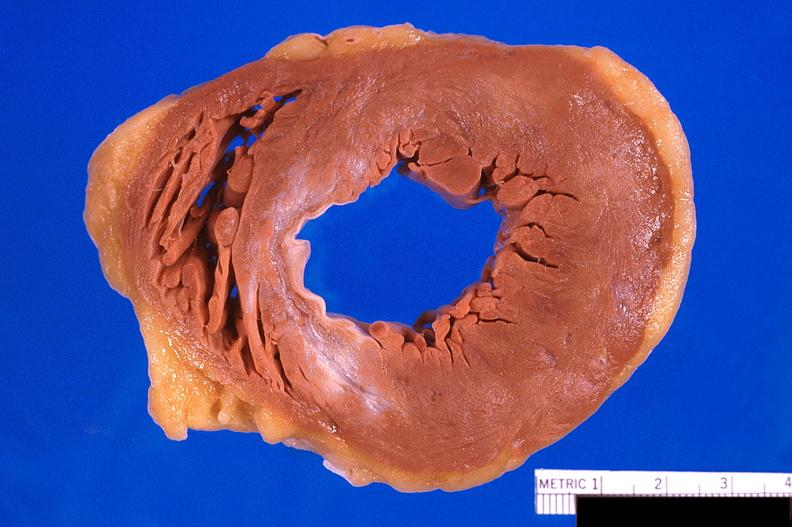how does this image show heart, old myocardial infarction?
Answer the question using a single word or phrase. With fibrosis 